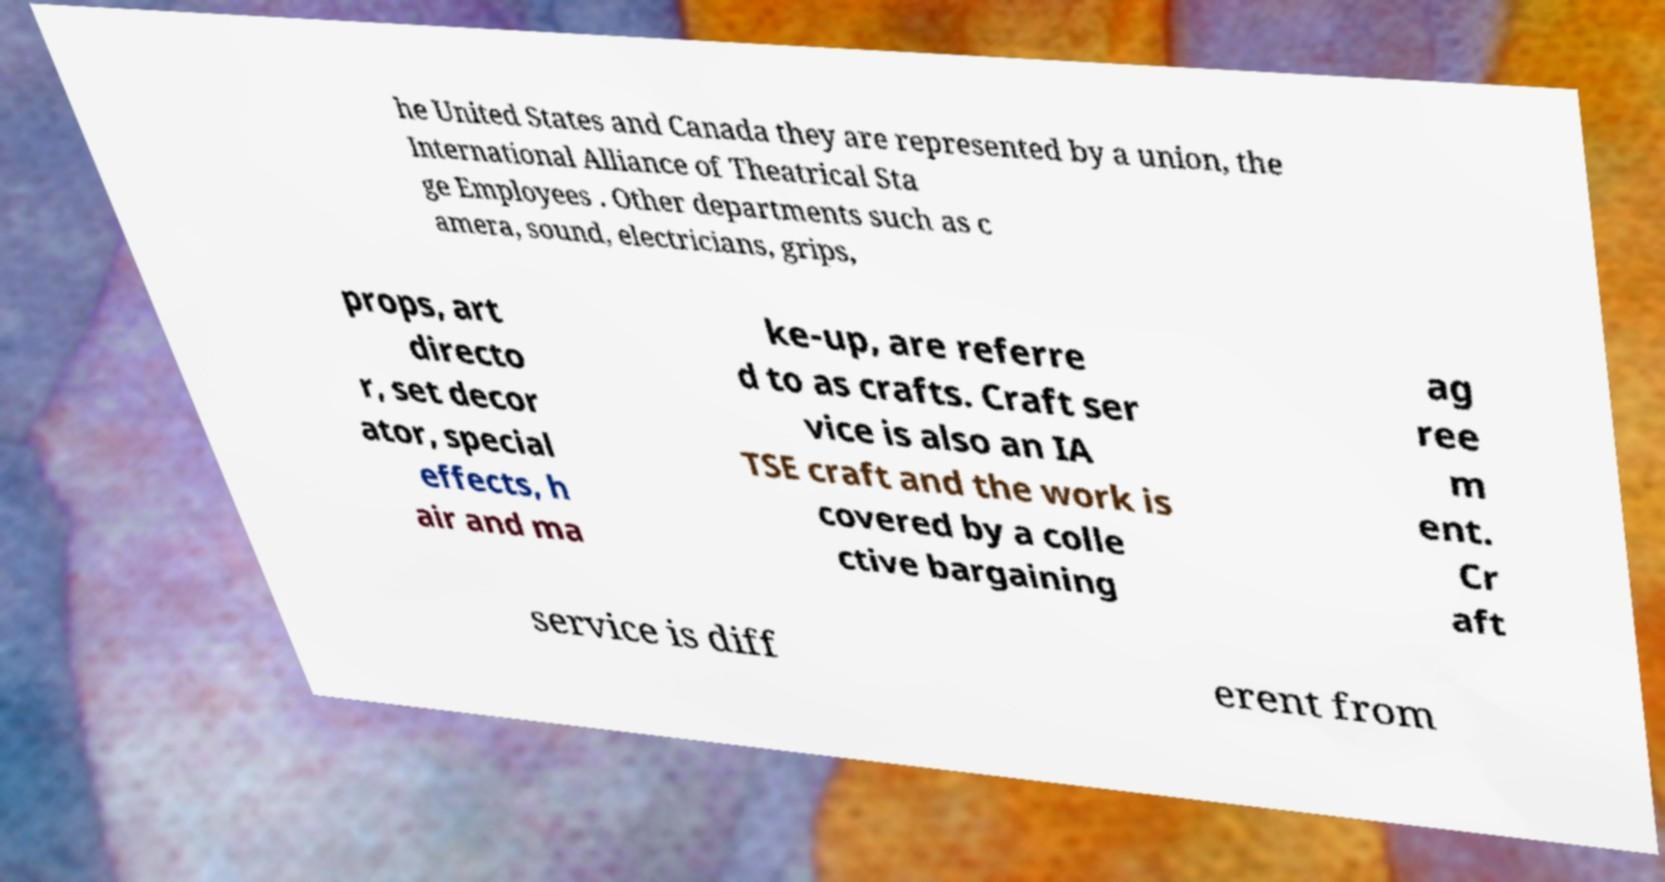Can you accurately transcribe the text from the provided image for me? he United States and Canada they are represented by a union, the International Alliance of Theatrical Sta ge Employees . Other departments such as c amera, sound, electricians, grips, props, art directo r, set decor ator, special effects, h air and ma ke-up, are referre d to as crafts. Craft ser vice is also an IA TSE craft and the work is covered by a colle ctive bargaining ag ree m ent. Cr aft service is diff erent from 